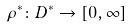<formula> <loc_0><loc_0><loc_500><loc_500>\rho ^ { * } \colon D ^ { * } \rightarrow [ 0 , \infty ]</formula> 